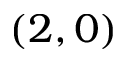<formula> <loc_0><loc_0><loc_500><loc_500>( 2 , 0 )</formula> 